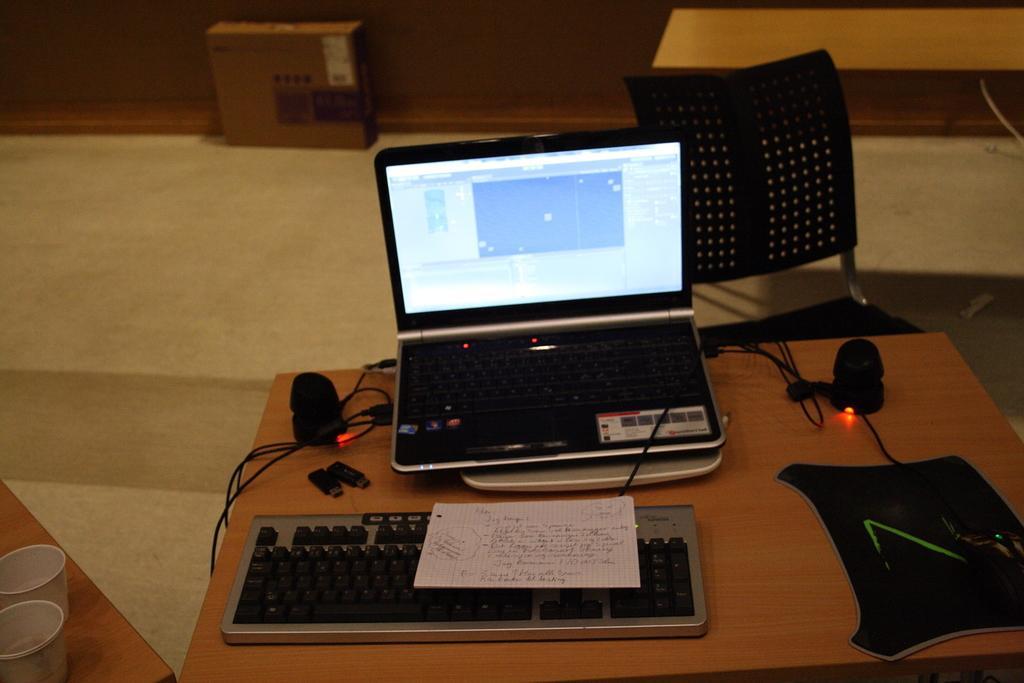How would you summarize this image in a sentence or two? In the center of the image there is a table. There is a laptop, keyboard, wires, paper, mouse and mouse pad placed on the table. There is a chair. In the background there is a box, bench and wall. 